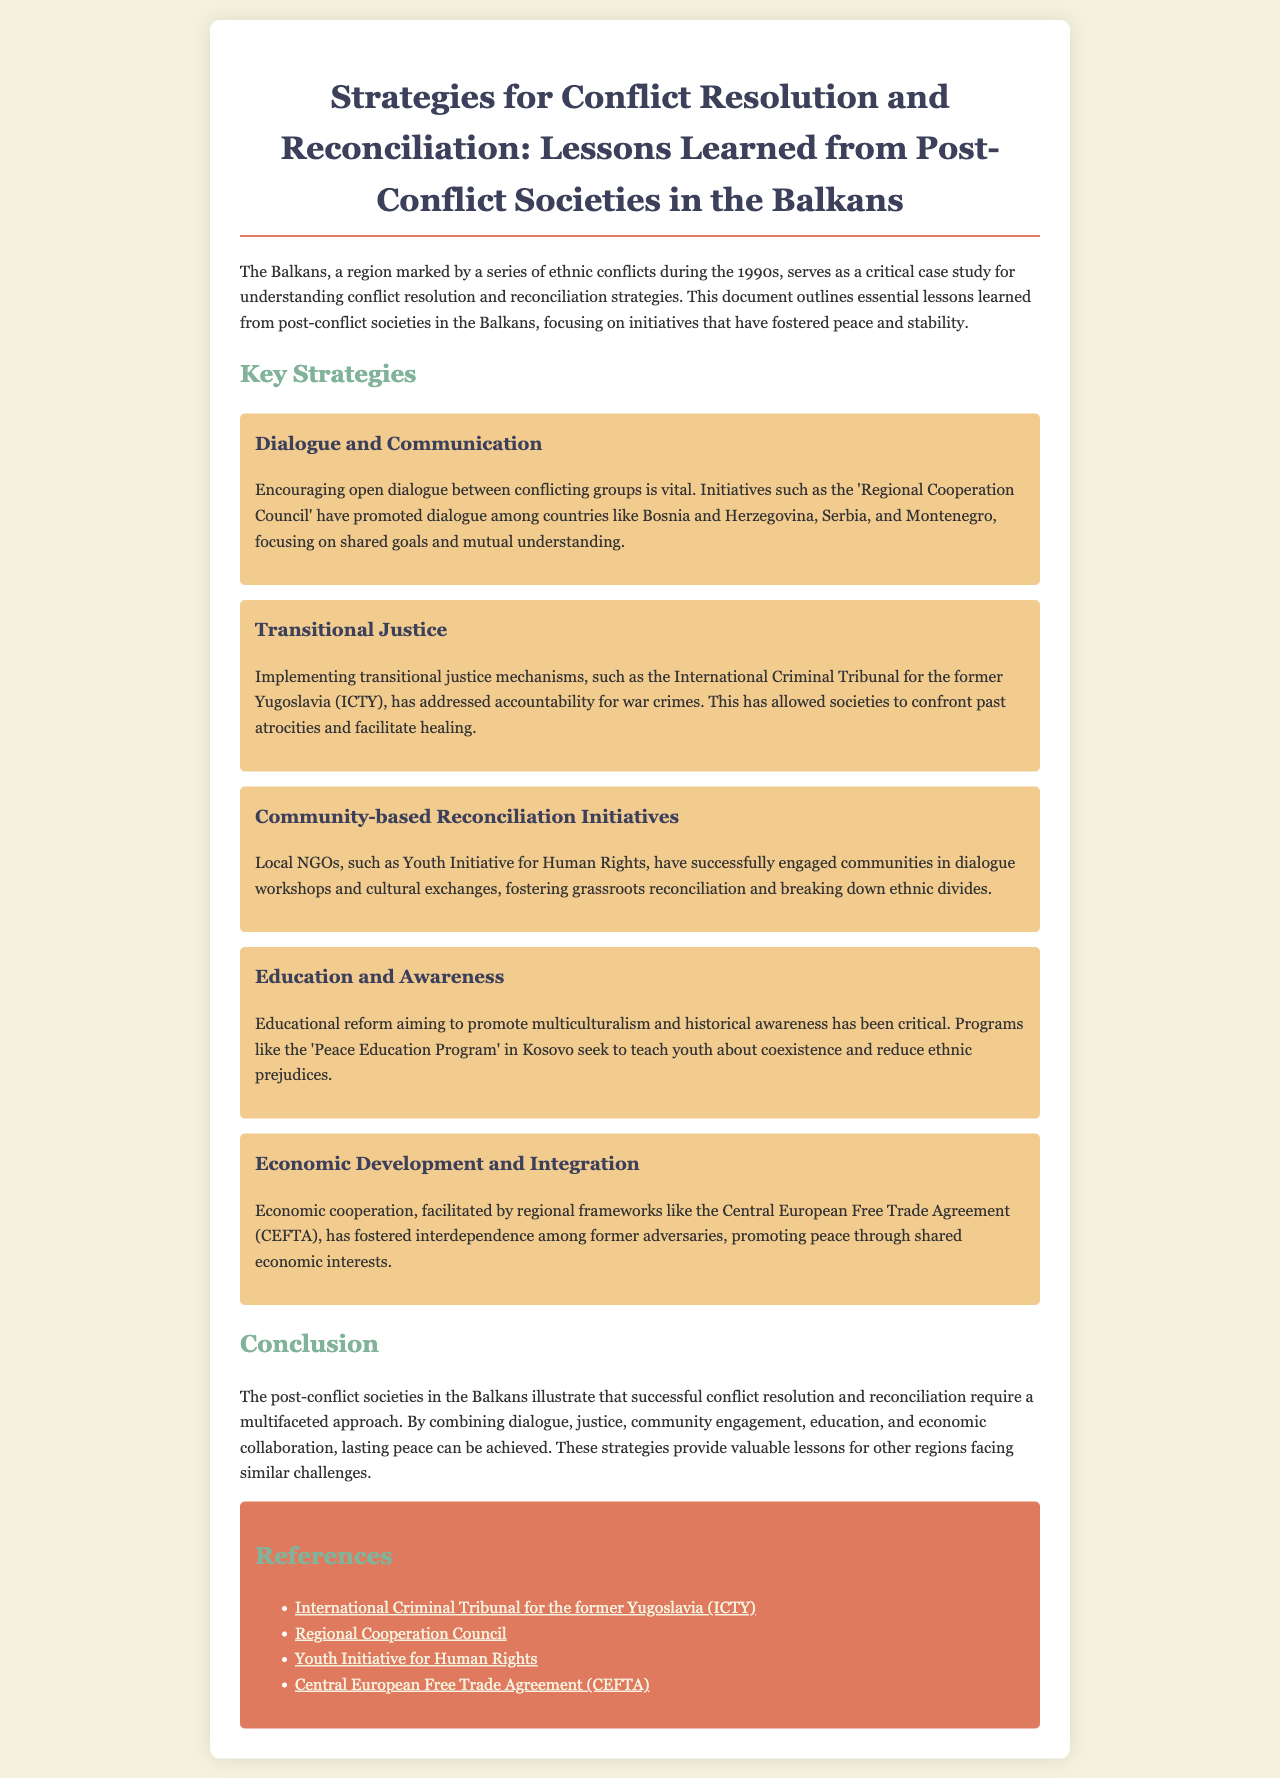What is the title of the document? The title of the document is indicated at the beginning of the report.
Answer: Strategies for Conflict Resolution and Reconciliation: Lessons Learned from Post-Conflict Societies in the Balkans Which international tribunal addressed war crimes in the Balkans? The document mentions the International Criminal Tribunal for the former Yugoslavia specifically addressing accountability for war crimes.
Answer: International Criminal Tribunal for the former Yugoslavia (ICTY) What initiative promoted dialogue among Bosnia and Herzegovina, Serbia, and Montenegro? The report highlights the 'Regional Cooperation Council' as an initiative that encouraged dialogue among the mentioned countries.
Answer: Regional Cooperation Council What is one key component of education reform mentioned in the document? The document discusses the importance of promoting multiculturalism and historical awareness as part of educational reform.
Answer: Multiculturalism and historical awareness Name one local NGO involved in community-based reconciliation initiatives. The report identifies the 'Youth Initiative for Human Rights' as an active local NGO in community engagement and reconciliation efforts.
Answer: Youth Initiative for Human Rights How many strategies for conflict resolution are outlined in the document? The document lists a total of five strategies for conflict resolution and reconciliation.
Answer: Five What does the 'Peace Education Program' aim to reduce? The document indicates that the 'Peace Education Program' seeks to reduce ethnic prejudices among youth.
Answer: Ethnic prejudices What economic framework is mentioned that fosters interdependence? The document refers to the Central European Free Trade Agreement (CEFTA) as a regional framework promoting economic cooperation.
Answer: Central European Free Trade Agreement (CEFTA) 